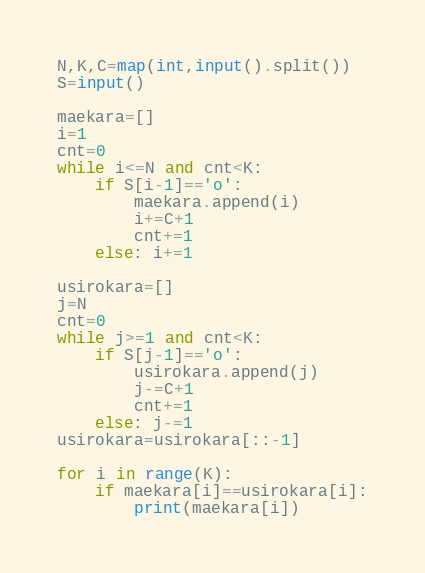<code> <loc_0><loc_0><loc_500><loc_500><_Python_>N,K,C=map(int,input().split())
S=input()

maekara=[]
i=1
cnt=0
while i<=N and cnt<K:
    if S[i-1]=='o':
        maekara.append(i)
        i+=C+1
        cnt+=1
    else: i+=1

usirokara=[]
j=N
cnt=0
while j>=1 and cnt<K:
    if S[j-1]=='o':
        usirokara.append(j)
        j-=C+1
        cnt+=1
    else: j-=1
usirokara=usirokara[::-1]

for i in range(K):
    if maekara[i]==usirokara[i]:
        print(maekara[i])
</code> 